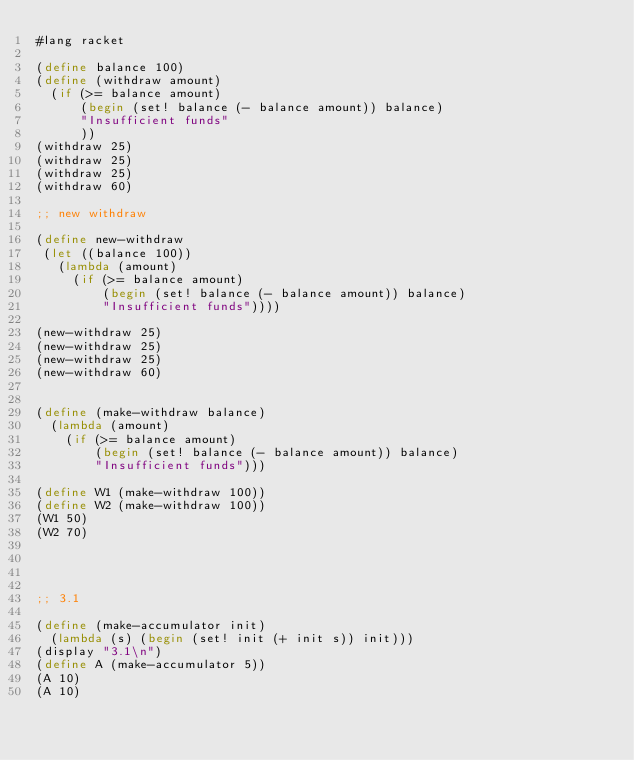<code> <loc_0><loc_0><loc_500><loc_500><_Scheme_>#lang racket

(define balance 100)
(define (withdraw amount)
  (if (>= balance amount) 
      (begin (set! balance (- balance amount)) balance)
      "Insufficient funds"
      ))
(withdraw 25)
(withdraw 25)
(withdraw 25)
(withdraw 60)

;; new withdraw

(define new-withdraw
 (let ((balance 100))
   (lambda (amount) 
     (if (>= balance amount)
         (begin (set! balance (- balance amount)) balance)
         "Insufficient funds"))))

(new-withdraw 25)
(new-withdraw 25)
(new-withdraw 25)
(new-withdraw 60)


(define (make-withdraw balance)
  (lambda (amount)
    (if (>= balance amount)
        (begin (set! balance (- balance amount)) balance)
        "Insufficient funds")))

(define W1 (make-withdraw 100))
(define W2 (make-withdraw 100))
(W1 50)
(W2 70)




;; 3.1

(define (make-accumulator init)
  (lambda (s) (begin (set! init (+ init s)) init)))
(display "3.1\n")
(define A (make-accumulator 5))
(A 10)
(A 10)</code> 